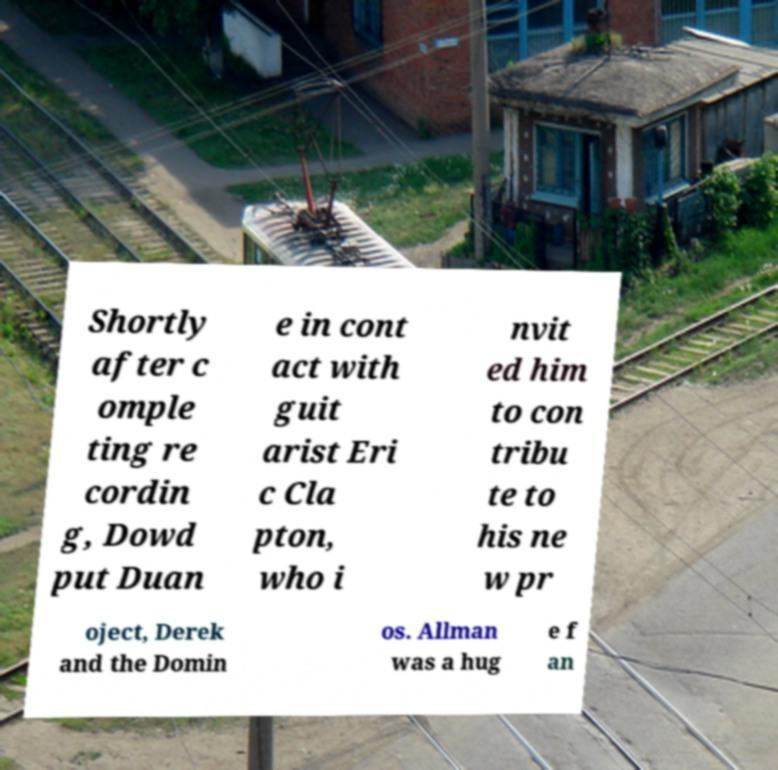Can you read and provide the text displayed in the image?This photo seems to have some interesting text. Can you extract and type it out for me? Shortly after c omple ting re cordin g, Dowd put Duan e in cont act with guit arist Eri c Cla pton, who i nvit ed him to con tribu te to his ne w pr oject, Derek and the Domin os. Allman was a hug e f an 